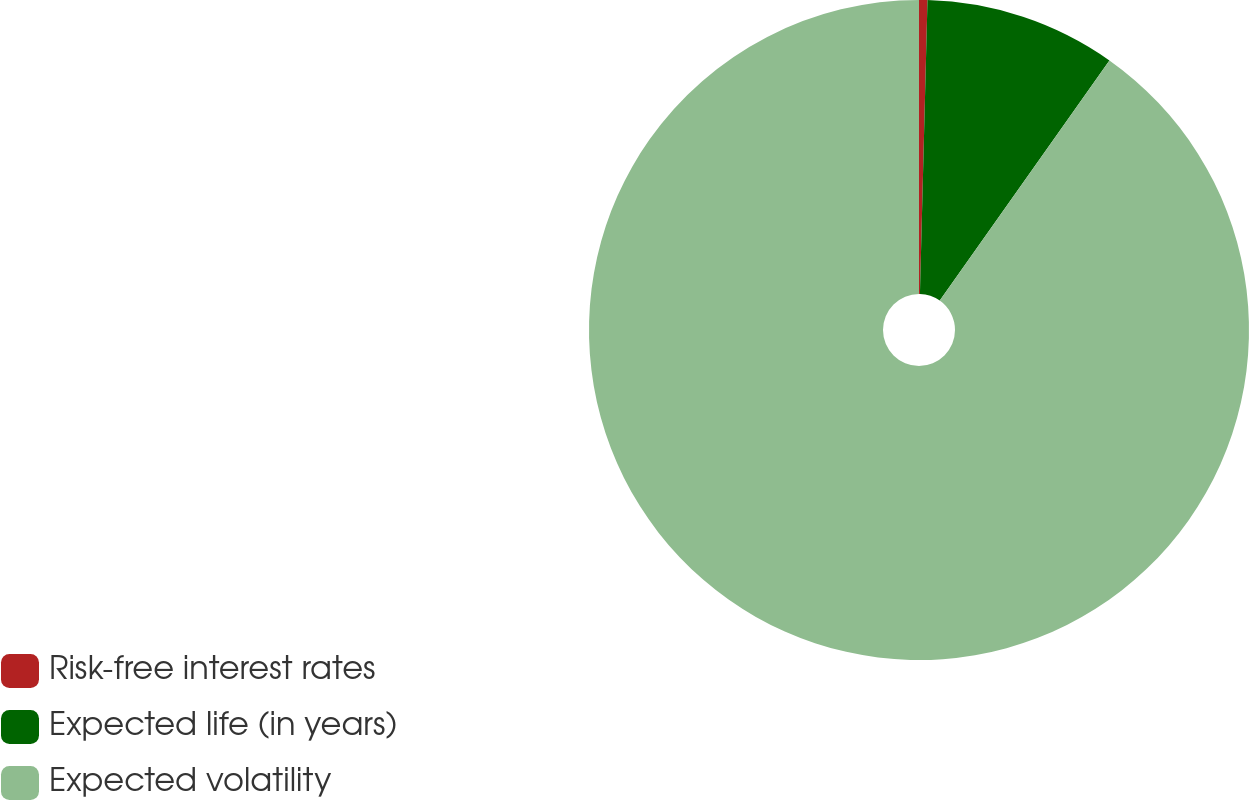<chart> <loc_0><loc_0><loc_500><loc_500><pie_chart><fcel>Risk-free interest rates<fcel>Expected life (in years)<fcel>Expected volatility<nl><fcel>0.41%<fcel>9.38%<fcel>90.21%<nl></chart> 